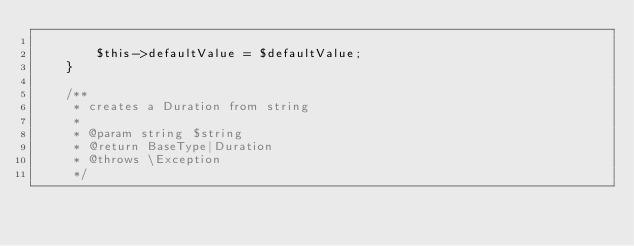<code> <loc_0><loc_0><loc_500><loc_500><_PHP_>
        $this->defaultValue = $defaultValue;
    }

    /**
     * creates a Duration from string
     *
     * @param string $string
     * @return BaseType|Duration
     * @throws \Exception
     */</code> 